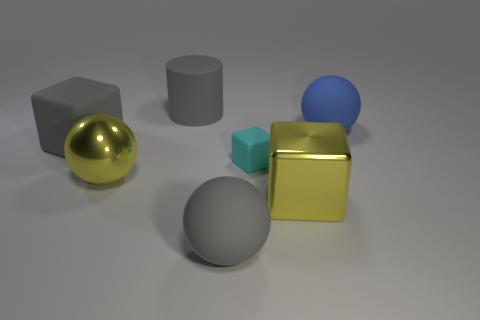Subtract 1 blocks. How many blocks are left? 2 Add 3 large things. How many objects exist? 10 Subtract all cubes. How many objects are left? 4 Subtract all big rubber things. Subtract all big purple rubber cubes. How many objects are left? 3 Add 2 shiny things. How many shiny things are left? 4 Add 5 gray spheres. How many gray spheres exist? 6 Subtract 1 gray balls. How many objects are left? 6 